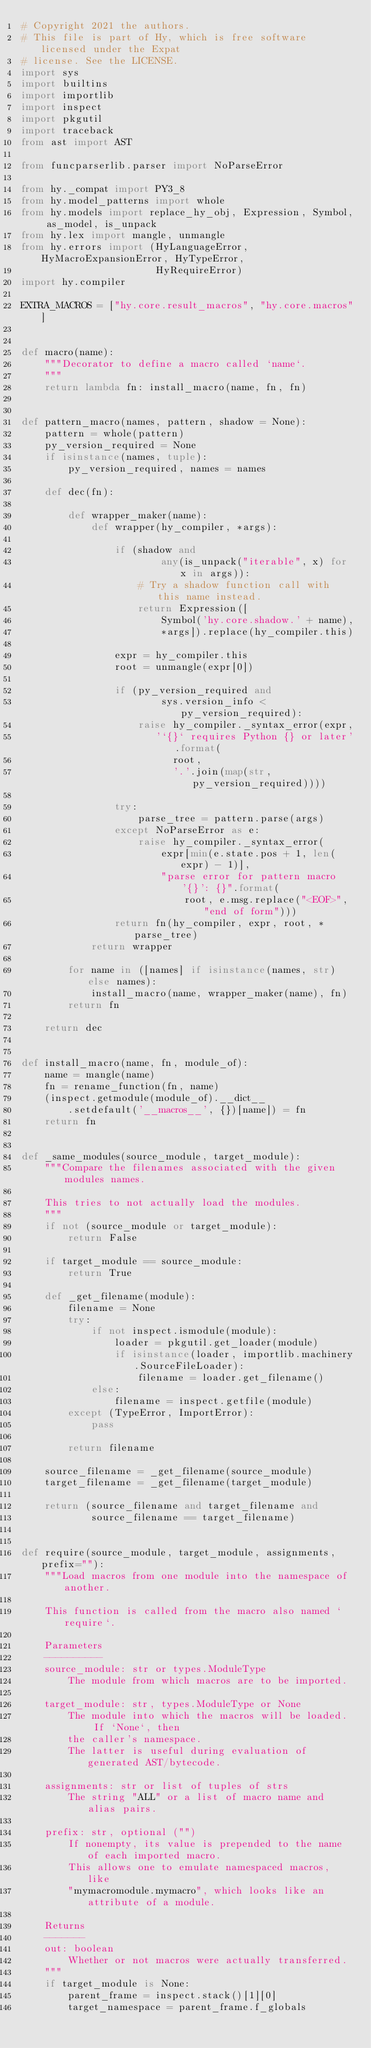Convert code to text. <code><loc_0><loc_0><loc_500><loc_500><_Python_># Copyright 2021 the authors.
# This file is part of Hy, which is free software licensed under the Expat
# license. See the LICENSE.
import sys
import builtins
import importlib
import inspect
import pkgutil
import traceback
from ast import AST

from funcparserlib.parser import NoParseError

from hy._compat import PY3_8
from hy.model_patterns import whole
from hy.models import replace_hy_obj, Expression, Symbol, as_model, is_unpack
from hy.lex import mangle, unmangle
from hy.errors import (HyLanguageError, HyMacroExpansionError, HyTypeError,
                       HyRequireError)
import hy.compiler

EXTRA_MACROS = ["hy.core.result_macros", "hy.core.macros"]


def macro(name):
    """Decorator to define a macro called `name`.
    """
    return lambda fn: install_macro(name, fn, fn)


def pattern_macro(names, pattern, shadow = None):
    pattern = whole(pattern)
    py_version_required = None
    if isinstance(names, tuple):
        py_version_required, names = names

    def dec(fn):

        def wrapper_maker(name):
            def wrapper(hy_compiler, *args):

                if (shadow and
                        any(is_unpack("iterable", x) for x in args)):
                    # Try a shadow function call with this name instead.
                    return Expression([
                        Symbol('hy.core.shadow.' + name),
                        *args]).replace(hy_compiler.this)

                expr = hy_compiler.this
                root = unmangle(expr[0])

                if (py_version_required and
                        sys.version_info < py_version_required):
                    raise hy_compiler._syntax_error(expr,
                       '`{}` requires Python {} or later'.format(
                          root,
                          '.'.join(map(str, py_version_required))))

                try:
                    parse_tree = pattern.parse(args)
                except NoParseError as e:
                    raise hy_compiler._syntax_error(
                        expr[min(e.state.pos + 1, len(expr) - 1)],
                        "parse error for pattern macro '{}': {}".format(
                            root, e.msg.replace("<EOF>", "end of form")))
                return fn(hy_compiler, expr, root, *parse_tree)
            return wrapper

        for name in ([names] if isinstance(names, str) else names):
            install_macro(name, wrapper_maker(name), fn)
        return fn

    return dec


def install_macro(name, fn, module_of):
    name = mangle(name)
    fn = rename_function(fn, name)
    (inspect.getmodule(module_of).__dict__
        .setdefault('__macros__', {})[name]) = fn
    return fn


def _same_modules(source_module, target_module):
    """Compare the filenames associated with the given modules names.

    This tries to not actually load the modules.
    """
    if not (source_module or target_module):
        return False

    if target_module == source_module:
        return True

    def _get_filename(module):
        filename = None
        try:
            if not inspect.ismodule(module):
                loader = pkgutil.get_loader(module)
                if isinstance(loader, importlib.machinery.SourceFileLoader):
                    filename = loader.get_filename()
            else:
                filename = inspect.getfile(module)
        except (TypeError, ImportError):
            pass

        return filename

    source_filename = _get_filename(source_module)
    target_filename = _get_filename(target_module)

    return (source_filename and target_filename and
            source_filename == target_filename)


def require(source_module, target_module, assignments, prefix=""):
    """Load macros from one module into the namespace of another.

    This function is called from the macro also named `require`.

    Parameters
    ----------
    source_module: str or types.ModuleType
        The module from which macros are to be imported.

    target_module: str, types.ModuleType or None
        The module into which the macros will be loaded.  If `None`, then
        the caller's namespace.
        The latter is useful during evaluation of generated AST/bytecode.

    assignments: str or list of tuples of strs
        The string "ALL" or a list of macro name and alias pairs.

    prefix: str, optional ("")
        If nonempty, its value is prepended to the name of each imported macro.
        This allows one to emulate namespaced macros, like
        "mymacromodule.mymacro", which looks like an attribute of a module.

    Returns
    -------
    out: boolean
        Whether or not macros were actually transferred.
    """
    if target_module is None:
        parent_frame = inspect.stack()[1][0]
        target_namespace = parent_frame.f_globals</code> 